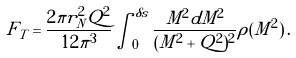<formula> <loc_0><loc_0><loc_500><loc_500>F _ { T } = \frac { 2 \pi r _ { N } ^ { 2 } Q ^ { 2 } } { 1 2 \pi ^ { 3 } } \int _ { 0 } ^ { \delta s } \frac { M ^ { 2 } d M ^ { 2 } } { ( M ^ { 2 } + Q ^ { 2 } ) ^ { 2 } } \rho ( M ^ { 2 } ) \, .</formula> 